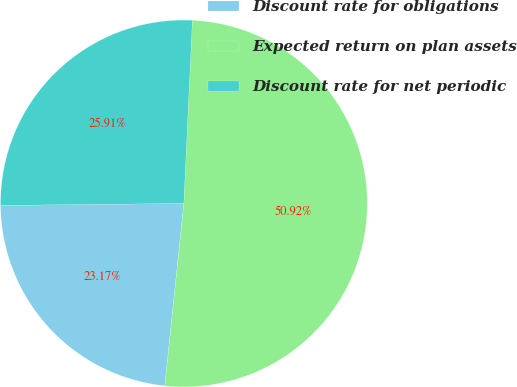Convert chart to OTSL. <chart><loc_0><loc_0><loc_500><loc_500><pie_chart><fcel>Discount rate for obligations<fcel>Expected return on plan assets<fcel>Discount rate for net periodic<nl><fcel>23.17%<fcel>50.91%<fcel>25.91%<nl></chart> 